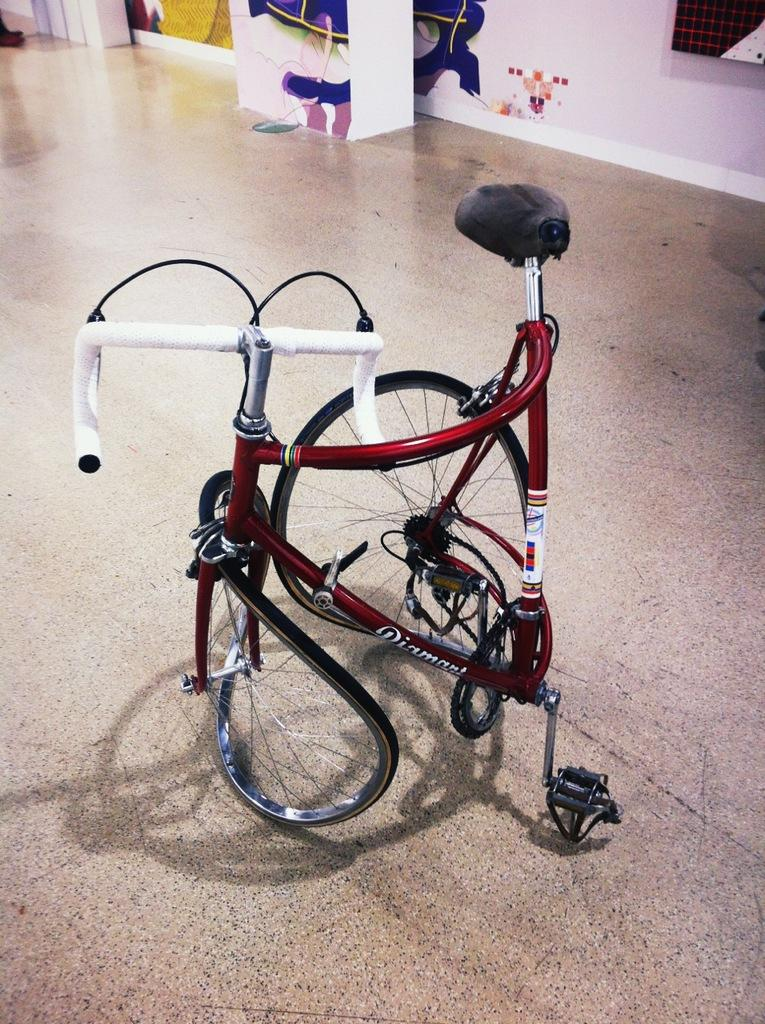What is the main object in the image? There is a bicycle in the image. How is the bicycle positioned in the image? The bicycle is twisted and on the floor. What can be seen in the background of the image? There is a wall in the background of the image. What is the house made of in the image? There is no house present in the image; it features a twisted bicycle on the floor with a wall in the background. How does the person's grip on the handlebars affect the bicycle's appearance in the image? There is no person present in the image, so we cannot determine how their grip on the handlebars would affect the bicycle's appearance. 